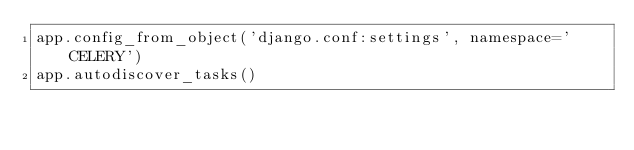<code> <loc_0><loc_0><loc_500><loc_500><_Python_>app.config_from_object('django.conf:settings', namespace='CELERY')
app.autodiscover_tasks()</code> 